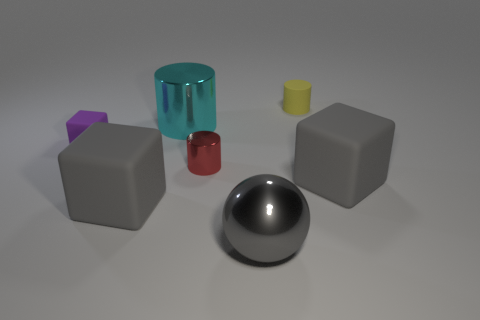Is there any other thing that is the same material as the red object?
Your answer should be compact. Yes. There is a purple rubber object; what shape is it?
Offer a terse response. Cube. What is the shape of the small rubber thing that is behind the large metallic thing that is behind the small red shiny cylinder?
Your response must be concise. Cylinder. Is the material of the large thing left of the large cylinder the same as the purple thing?
Provide a succinct answer. Yes. What number of yellow objects are metallic things or big rubber things?
Make the answer very short. 0. Are there any big cubes of the same color as the big metal cylinder?
Ensure brevity in your answer.  No. Are there any gray objects that have the same material as the tiny yellow thing?
Make the answer very short. Yes. The object that is both in front of the tiny red shiny object and right of the metallic sphere has what shape?
Make the answer very short. Cube. How many big things are purple rubber objects or gray blocks?
Your response must be concise. 2. What is the material of the yellow object?
Provide a short and direct response. Rubber. 